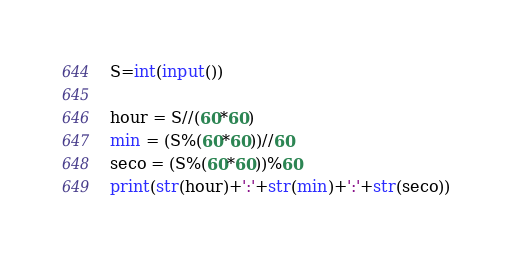Convert code to text. <code><loc_0><loc_0><loc_500><loc_500><_Python_>S=int(input())

hour = S//(60*60)
min = (S%(60*60))//60
seco = (S%(60*60))%60
print(str(hour)+':'+str(min)+':'+str(seco))

</code> 